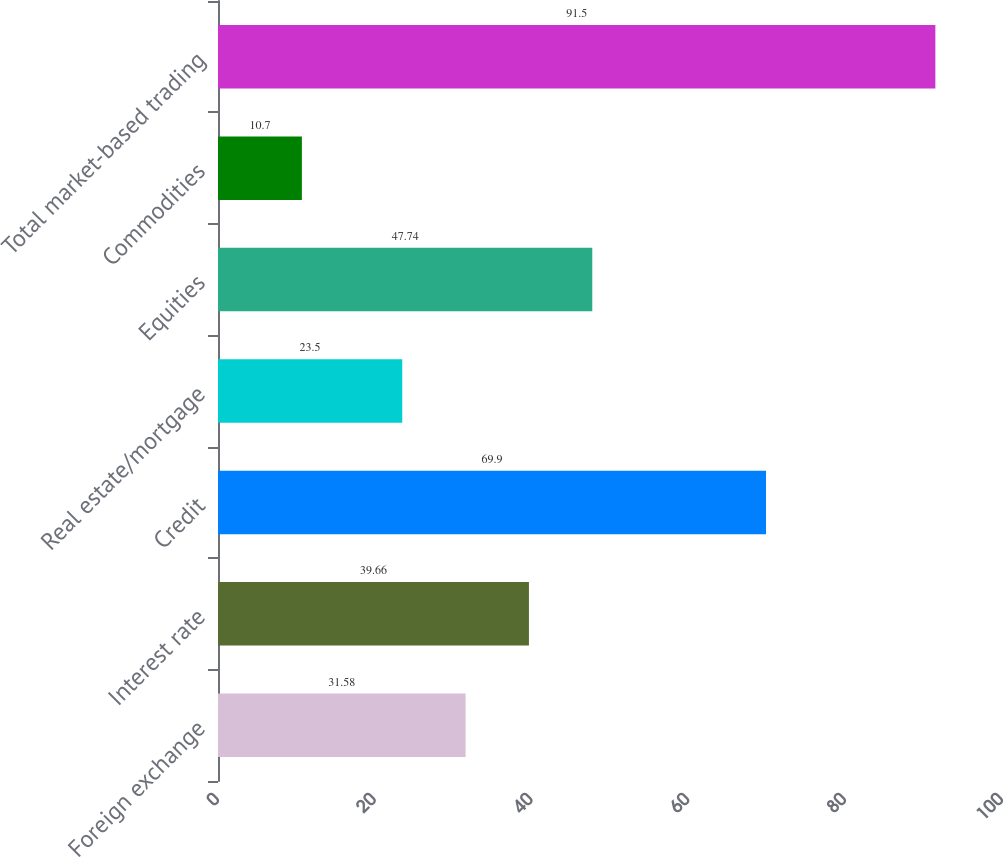Convert chart. <chart><loc_0><loc_0><loc_500><loc_500><bar_chart><fcel>Foreign exchange<fcel>Interest rate<fcel>Credit<fcel>Real estate/mortgage<fcel>Equities<fcel>Commodities<fcel>Total market-based trading<nl><fcel>31.58<fcel>39.66<fcel>69.9<fcel>23.5<fcel>47.74<fcel>10.7<fcel>91.5<nl></chart> 